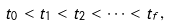<formula> <loc_0><loc_0><loc_500><loc_500>t _ { 0 } < t _ { 1 } < t _ { 2 } < \cdots < t _ { f } ,</formula> 